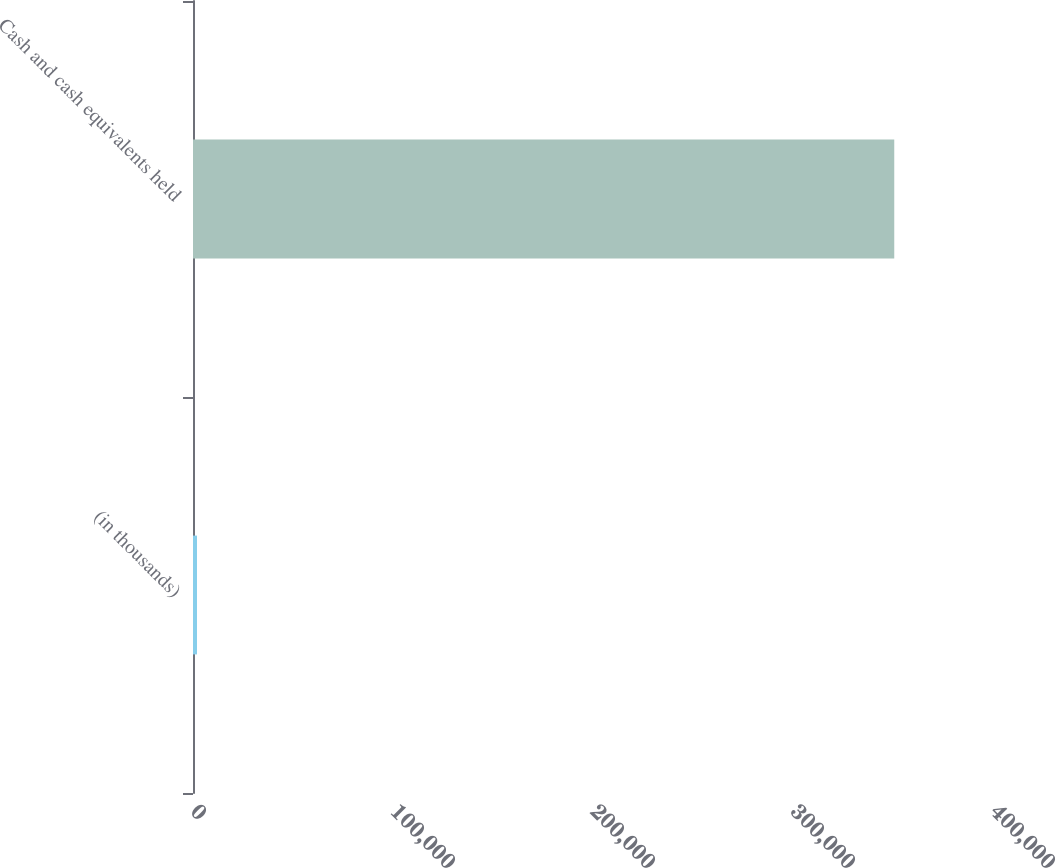Convert chart to OTSL. <chart><loc_0><loc_0><loc_500><loc_500><bar_chart><fcel>(in thousands)<fcel>Cash and cash equivalents held<nl><fcel>2014<fcel>350628<nl></chart> 